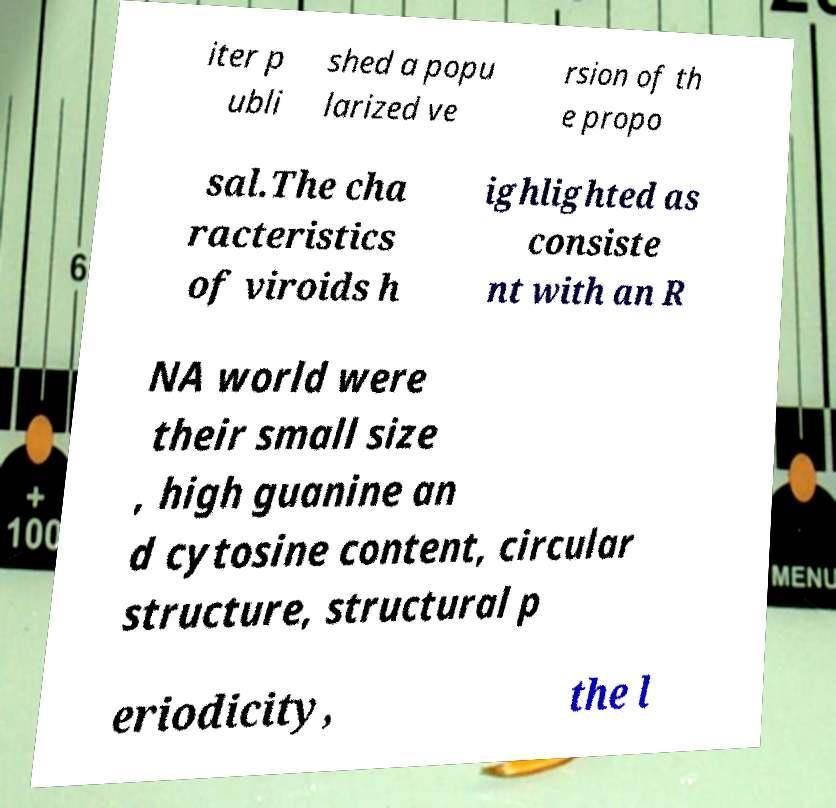There's text embedded in this image that I need extracted. Can you transcribe it verbatim? iter p ubli shed a popu larized ve rsion of th e propo sal.The cha racteristics of viroids h ighlighted as consiste nt with an R NA world were their small size , high guanine an d cytosine content, circular structure, structural p eriodicity, the l 